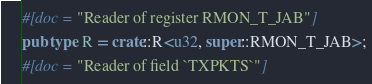Convert code to text. <code><loc_0><loc_0><loc_500><loc_500><_Rust_>#[doc = "Reader of register RMON_T_JAB"]
pub type R = crate::R<u32, super::RMON_T_JAB>;
#[doc = "Reader of field `TXPKTS`"]</code> 